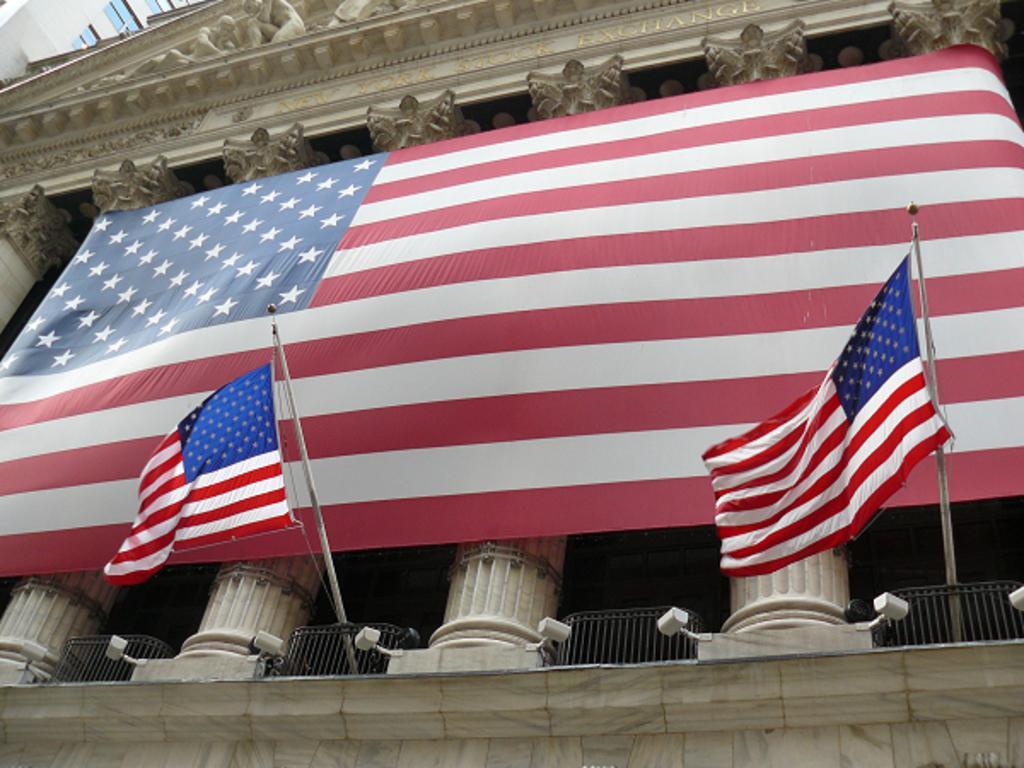How would you summarize this image in a sentence or two? In this image we can see the sculpture attached to the wall and there are flags, pillars and railing. And there are cameras attached to the wall. 